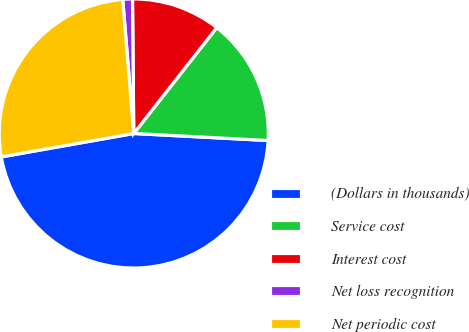Convert chart to OTSL. <chart><loc_0><loc_0><loc_500><loc_500><pie_chart><fcel>(Dollars in thousands)<fcel>Service cost<fcel>Interest cost<fcel>Net loss recognition<fcel>Net periodic cost<nl><fcel>46.39%<fcel>15.25%<fcel>10.73%<fcel>1.16%<fcel>26.48%<nl></chart> 